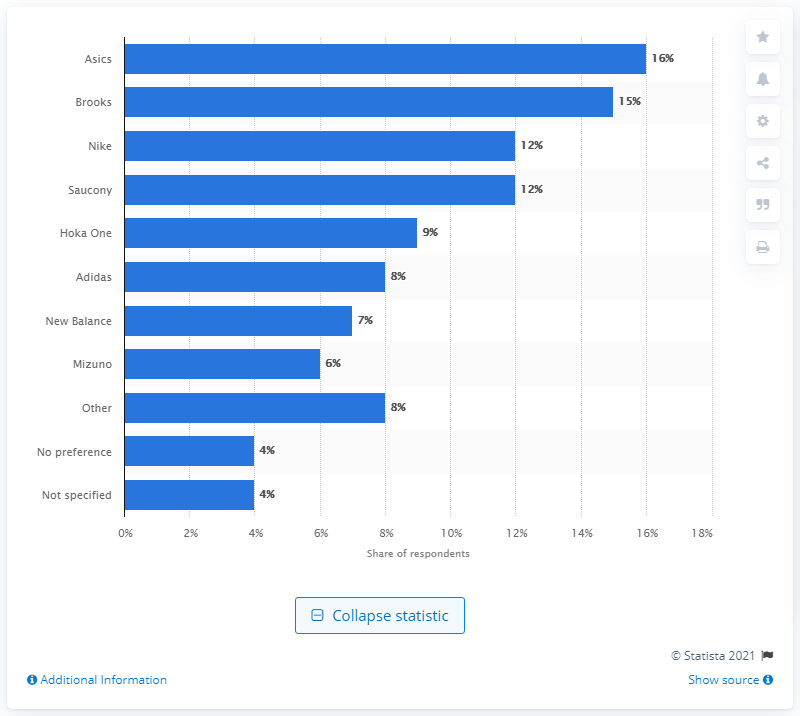Draw attention to some important aspects in this diagram. According to a survey conducted in late 2017, the favorite running shoe brand among respondents was Asics. 